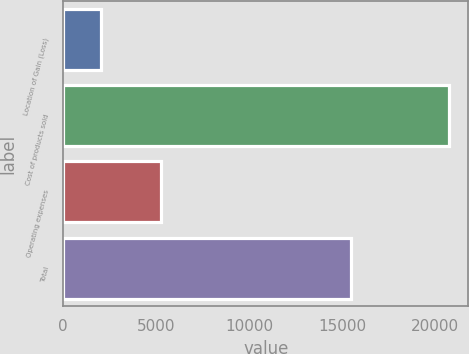<chart> <loc_0><loc_0><loc_500><loc_500><bar_chart><fcel>Location of Gain (Loss)<fcel>Cost of products sold<fcel>Operating expenses<fcel>Total<nl><fcel>2013<fcel>20751<fcel>5250<fcel>15501<nl></chart> 